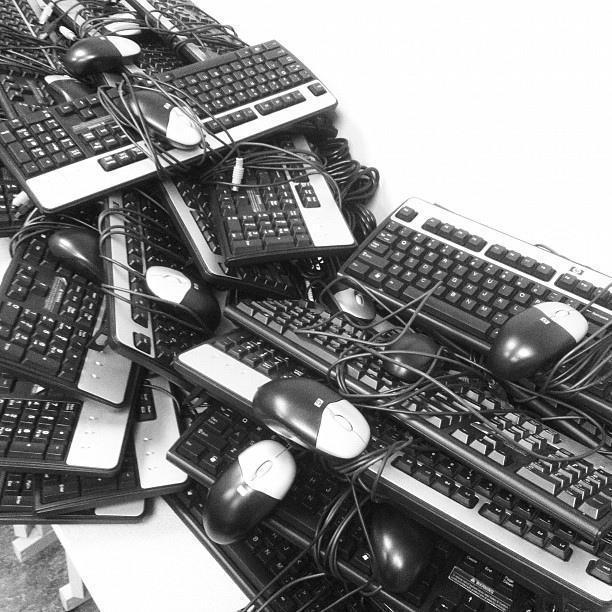Which one of these items would pair well with the items in the photo?
Select the accurate answer and provide explanation: 'Answer: answer
Rationale: rationale.'
Options: Monitor, clock, fireplace, pillow. Answer: monitor.
Rationale: A pile of keyboards and computer mice are visible. monitors go with keyboards and mice. 